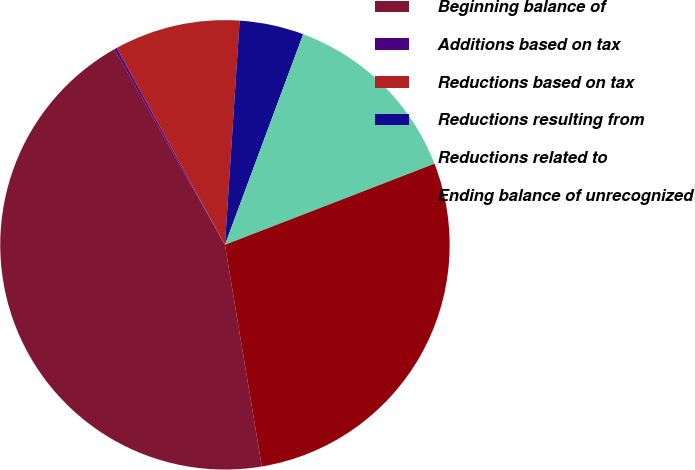<chart> <loc_0><loc_0><loc_500><loc_500><pie_chart><fcel>Beginning balance of<fcel>Additions based on tax<fcel>Reductions based on tax<fcel>Reductions resulting from<fcel>Reductions related to<fcel>Ending balance of unrecognized<nl><fcel>44.43%<fcel>0.19%<fcel>9.04%<fcel>4.62%<fcel>13.46%<fcel>28.25%<nl></chart> 